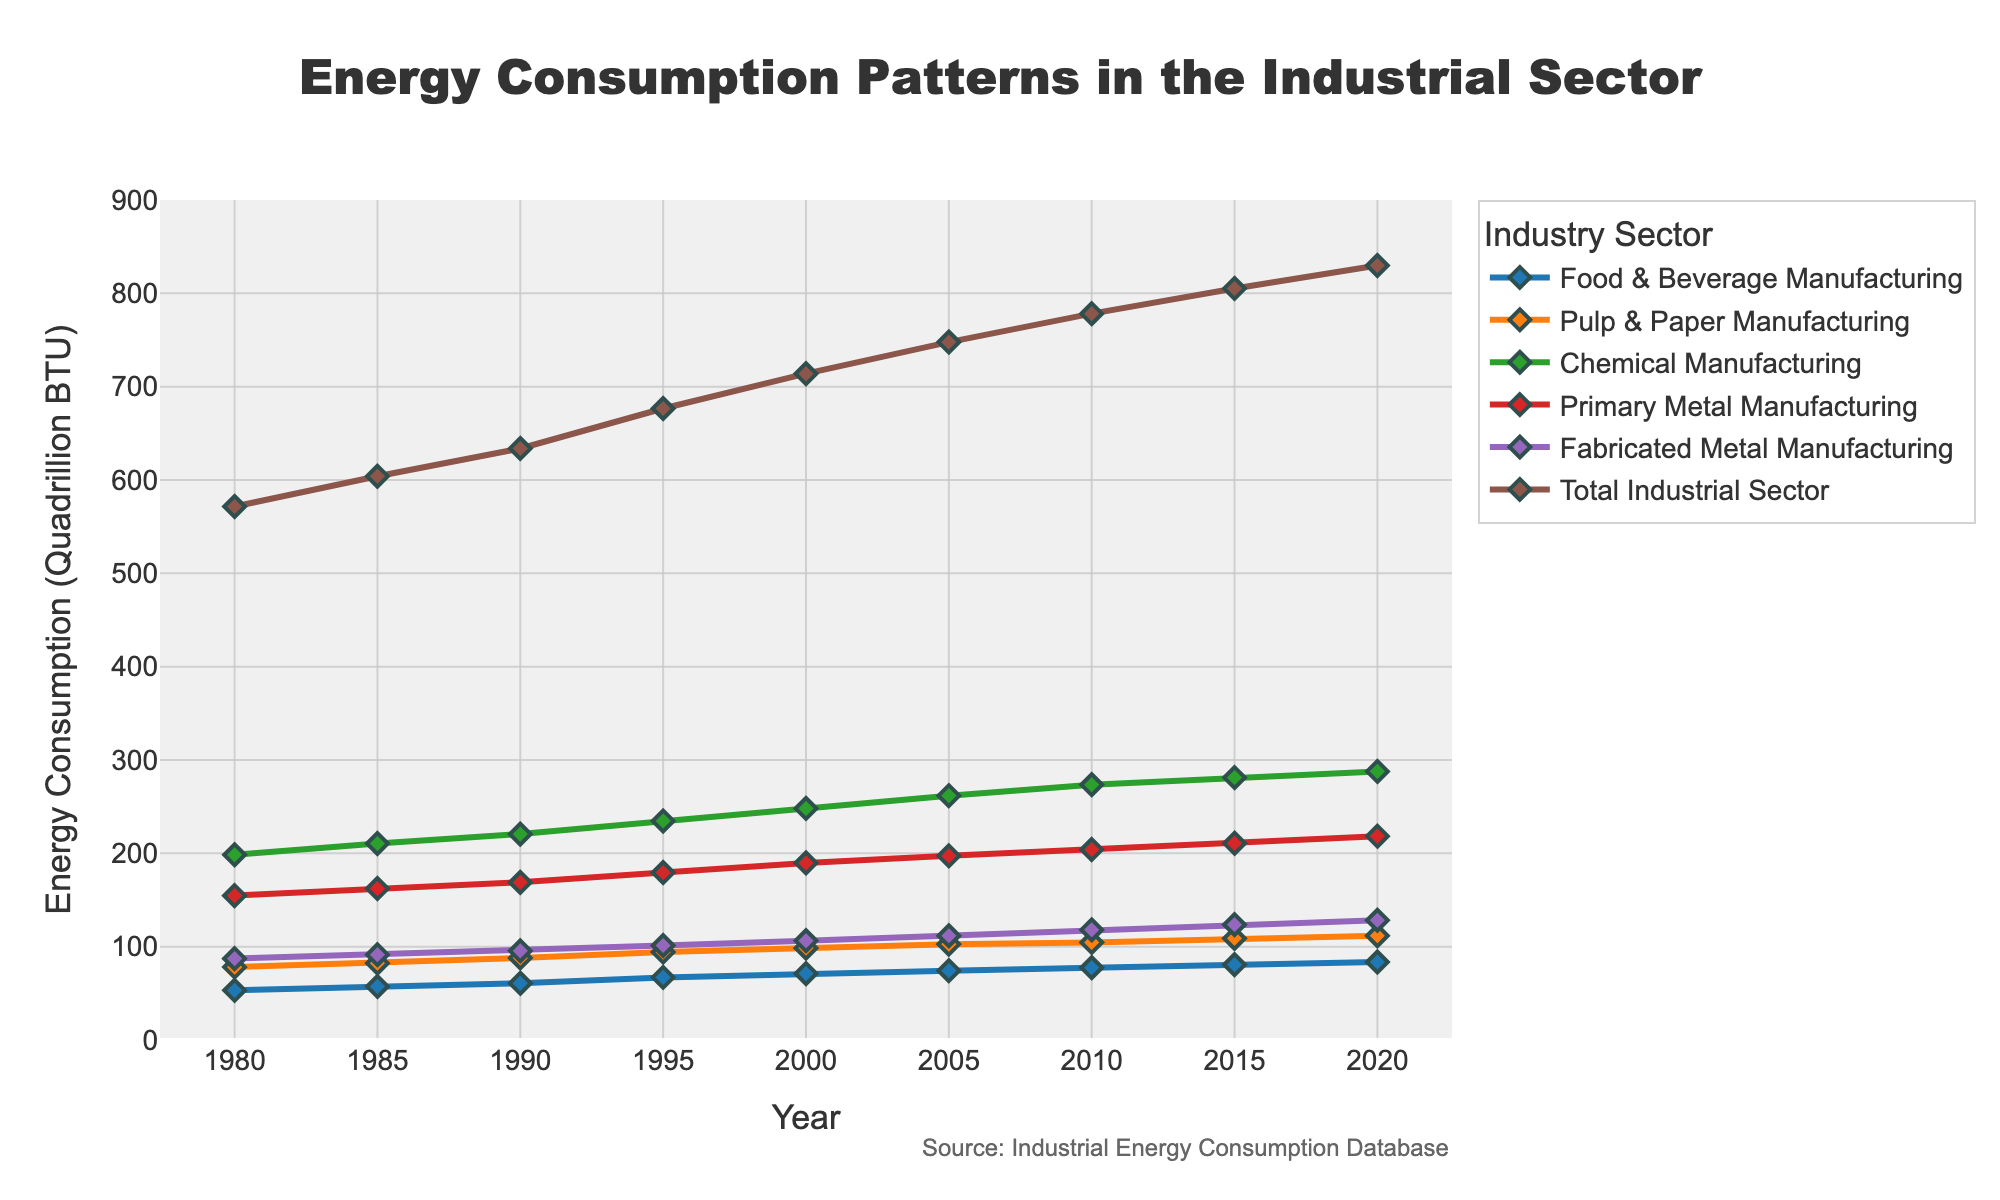What is the title of the plot? The title is located at the top of the figure and is labeled as 'Energy Consumption Patterns in the Industrial Sector'.
Answer: Energy Consumption Patterns in the Industrial Sector Which sector had the highest energy consumption in 1990? Locate the data point for the year 1990 and compare the values of energy consumption across different sectors. Chemical Manufacturing had the highest value at 220.6.
Answer: Chemical Manufacturing What is the total energy consumption of the industrial sector in 2015? Refer to the 'Total Industrial Sector' data for the year 2015, which is shown with a value of 805.2.
Answer: 805.2 How did the energy consumption in Primary Metal Manufacturing change from 1980 to 2020? Calculate the difference by comparing the values for Primary Metal Manufacturing in 1980 (154.7) and 2020 (218.4). The change is 218.4 - 154.7.
Answer: Increased by 63.7 Which sector has shown the most significant growth in energy consumption since 1980? Compare the initial and final values for each sector from 1980 to 2020. The Chemical Manufacturing sector grew from 198.4 to 287.8, a change of 89.4, which is the largest among the sectors.
Answer: Chemical Manufacturing In which year did the total energy consumption of the industrial sector exceed 700 quadrillion BTU for the first time? Look for the smallest year in the 'Total Industrial Sector' data that is greater than 700. The value first exceeds 700 in the year 2000, with 713.9.
Answer: 2000 How does the energy consumption in the Fabricated Metal Manufacturing sector in 2000 compare to that in 1995? Calculate the difference between the values in 2000 (106.4) and 1995 (101.2). The change is 106.4 - 101.2.
Answer: Increased by 5.2 What is the energy consumption trend for Pulp & Paper Manufacturing from 1980 to 2020? Observe the data points for Pulp & Paper Manufacturing over the years from 1980 (78.1) to 2020 (111.7). This sector shows a generally increasing trend.
Answer: Increasing trend 